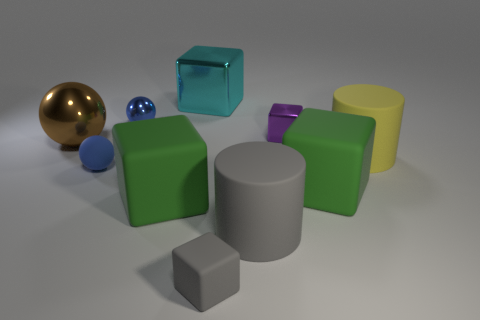Subtract all green blocks. How many were subtracted if there are1green blocks left? 1 Subtract all tiny purple metal blocks. How many blocks are left? 4 Subtract all cyan cubes. How many cubes are left? 4 Subtract all cyan spheres. How many green cubes are left? 2 Subtract 2 cubes. How many cubes are left? 3 Subtract all balls. How many objects are left? 7 Subtract 0 red balls. How many objects are left? 10 Subtract all red balls. Subtract all brown cubes. How many balls are left? 3 Subtract all purple metallic things. Subtract all cylinders. How many objects are left? 7 Add 6 tiny blue objects. How many tiny blue objects are left? 8 